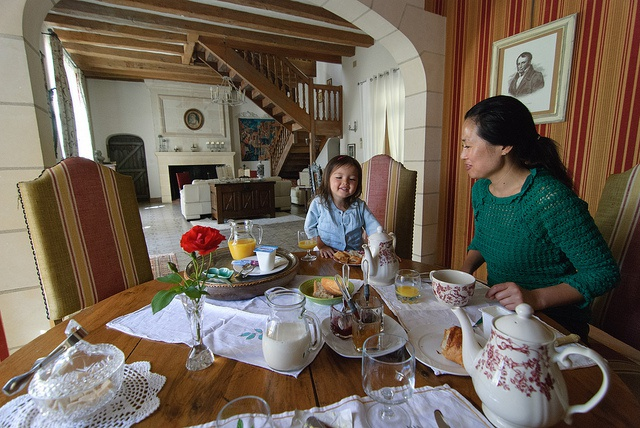Describe the objects in this image and their specific colors. I can see dining table in darkgray, maroon, gray, and black tones, people in darkgray, black, teal, gray, and maroon tones, chair in darkgray, maroon, olive, black, and gray tones, bowl in darkgray, lightgray, and gray tones, and people in darkgray, black, lightblue, and gray tones in this image. 